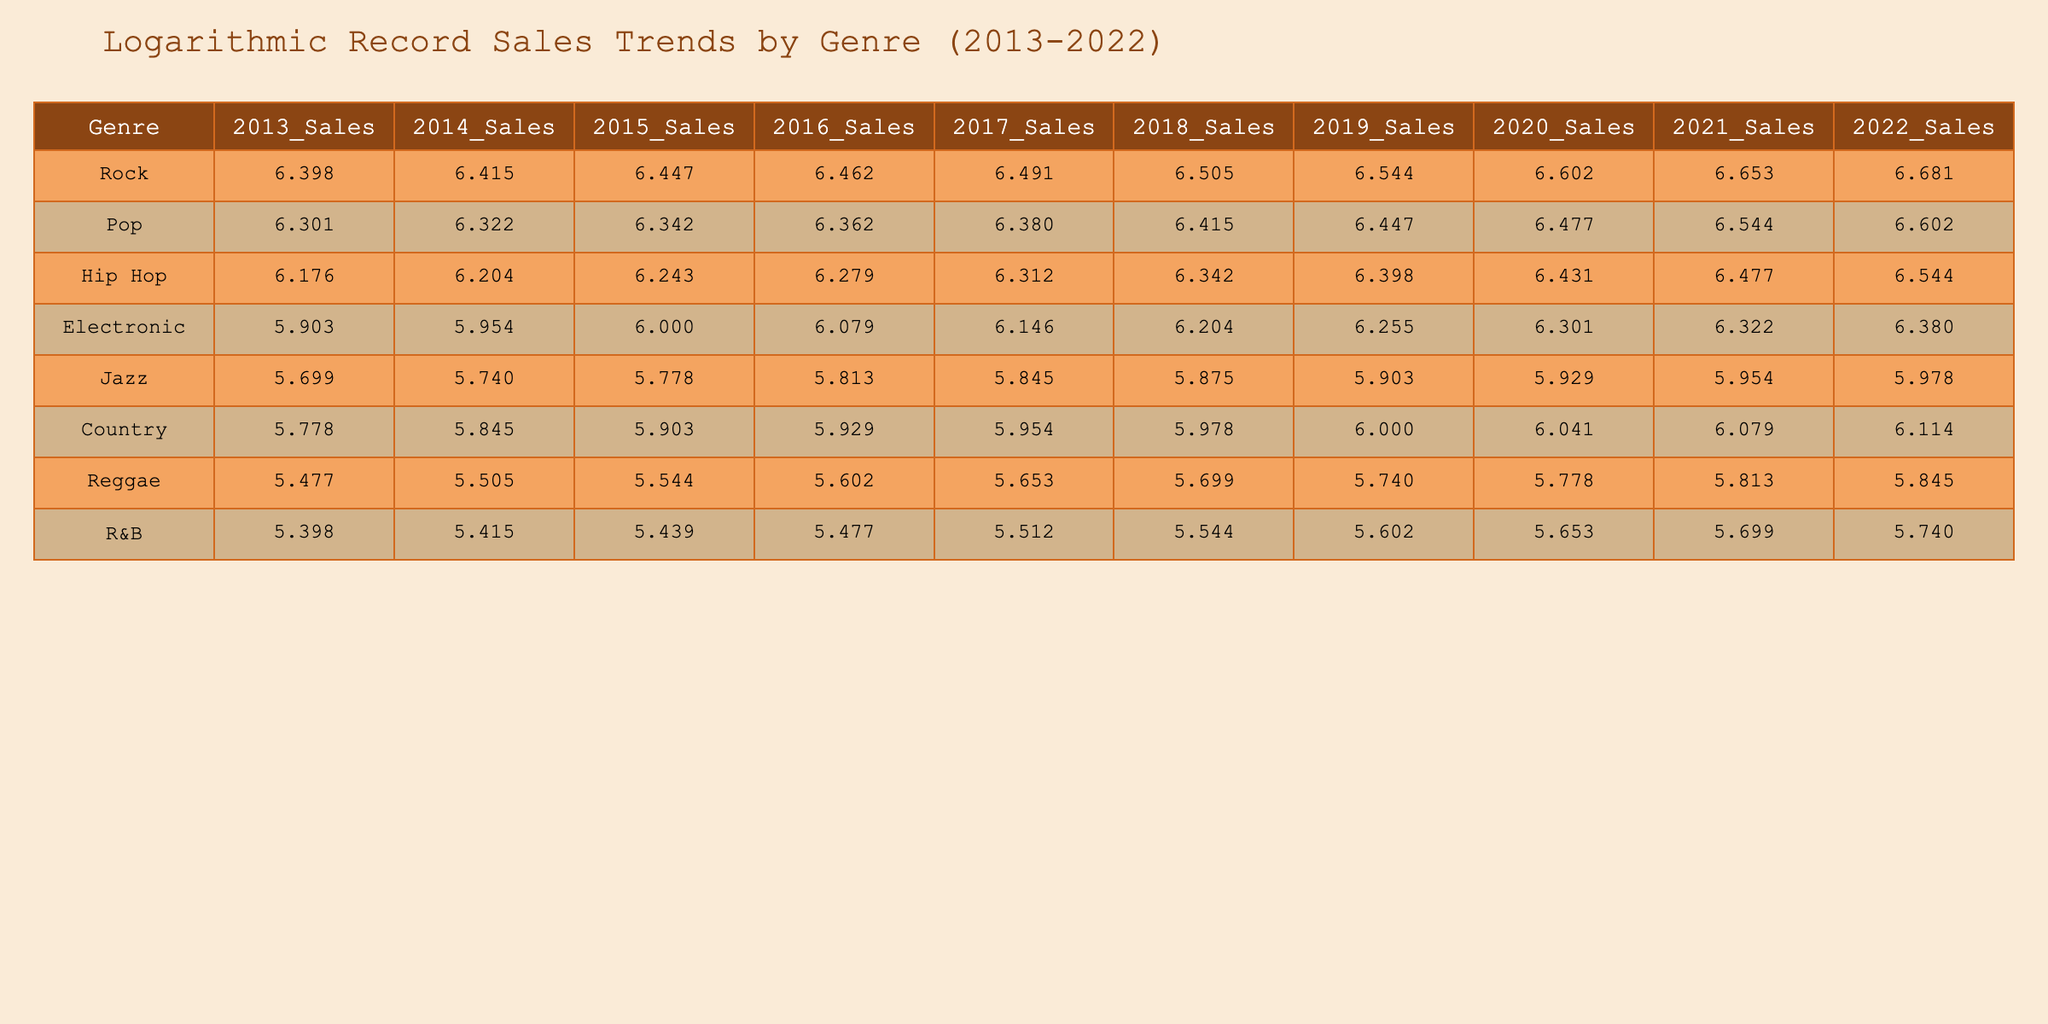What was the total sales for the Pop genre in 2018? To find the total sales for the Pop genre in 2018, I look at the table under the Pop column for the year 2018, which shows a value of 2600000.
Answer: 2600000 Which genre had the highest sales in 2022? I compare the sales values across all genres for the year 2022. The highest value is 4800000 in the Rock genre.
Answer: Rock What is the difference in sales between Hip Hop in 2013 and Hip Hop in 2022? I take the sales figure for Hip Hop in 2013, which is 1500000, and the sales figure in 2022, which is 3500000. The difference is 3500000 - 1500000 = 2000000.
Answer: 2000000 Has Jazz seen an increase in sales every year from 2013 to 2022? Looking at each year's sales for Jazz from 2013 to 2022, I see that the sales numbers keep rising: 500000, 550000, 600000, 650000, 700000, 750000, 800000, 850000, 900000, and 950000. Therefore, Jazz has seen consistent growth each year.
Answer: Yes What was the average sales figure for Electronic genre from 2013 to 2022? To find the average, I will sum the sales figures for Electronic from 2013 to 2022: 800000 + 900000 + 1000000 + 1200000 + 1400000 + 1600000 + 1800000 + 2000000 + 2100000 + 2400000 = 19600000. Then I divide by the total number of years, which is 10: 19600000 / 10 = 1960000.
Answer: 1960000 In which year did Country sales exceed 1000000 for the first time? By examining the sales data for Country, I see that the sales figure first exceeds 1000000 in 2019, which is 1100000. In the years prior, 2018 had 950000.
Answer: 2019 What was the sales trend for R&B from 2013 to 2022? I analyze the R&B sales figures: 250000, 260000, 275000, 300000, 325000, 350000, 400000, 450000, 500000, and 550000. The sales figures show a consistent increase each year, indicating a positive sales trend.
Answer: Increasing What genre had the least sales in 2020? Looking at the 2020 sales figures across all genres, I find that Reggae had the least sales at 600000.
Answer: Reggae 